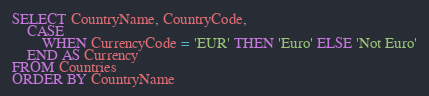<code> <loc_0><loc_0><loc_500><loc_500><_SQL_>SELECT CountryName, CountryCode,
	CASE 
		WHEN CurrencyCode = 'EUR' THEN 'Euro' ELSE 'Not Euro'
	END AS Currency
FROM Countries
ORDER BY CountryName
</code> 